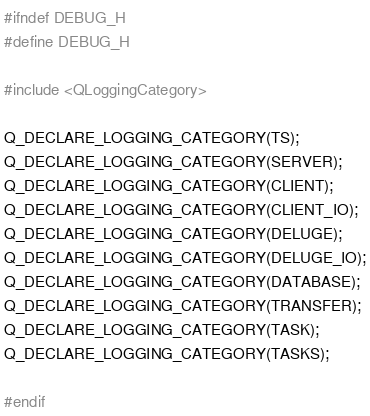Convert code to text. <code><loc_0><loc_0><loc_500><loc_500><_C_>#ifndef DEBUG_H
#define DEBUG_H

#include <QLoggingCategory>

Q_DECLARE_LOGGING_CATEGORY(TS);
Q_DECLARE_LOGGING_CATEGORY(SERVER);
Q_DECLARE_LOGGING_CATEGORY(CLIENT);
Q_DECLARE_LOGGING_CATEGORY(CLIENT_IO);
Q_DECLARE_LOGGING_CATEGORY(DELUGE);
Q_DECLARE_LOGGING_CATEGORY(DELUGE_IO);
Q_DECLARE_LOGGING_CATEGORY(DATABASE);
Q_DECLARE_LOGGING_CATEGORY(TRANSFER);
Q_DECLARE_LOGGING_CATEGORY(TASK);
Q_DECLARE_LOGGING_CATEGORY(TASKS);

#endif
</code> 